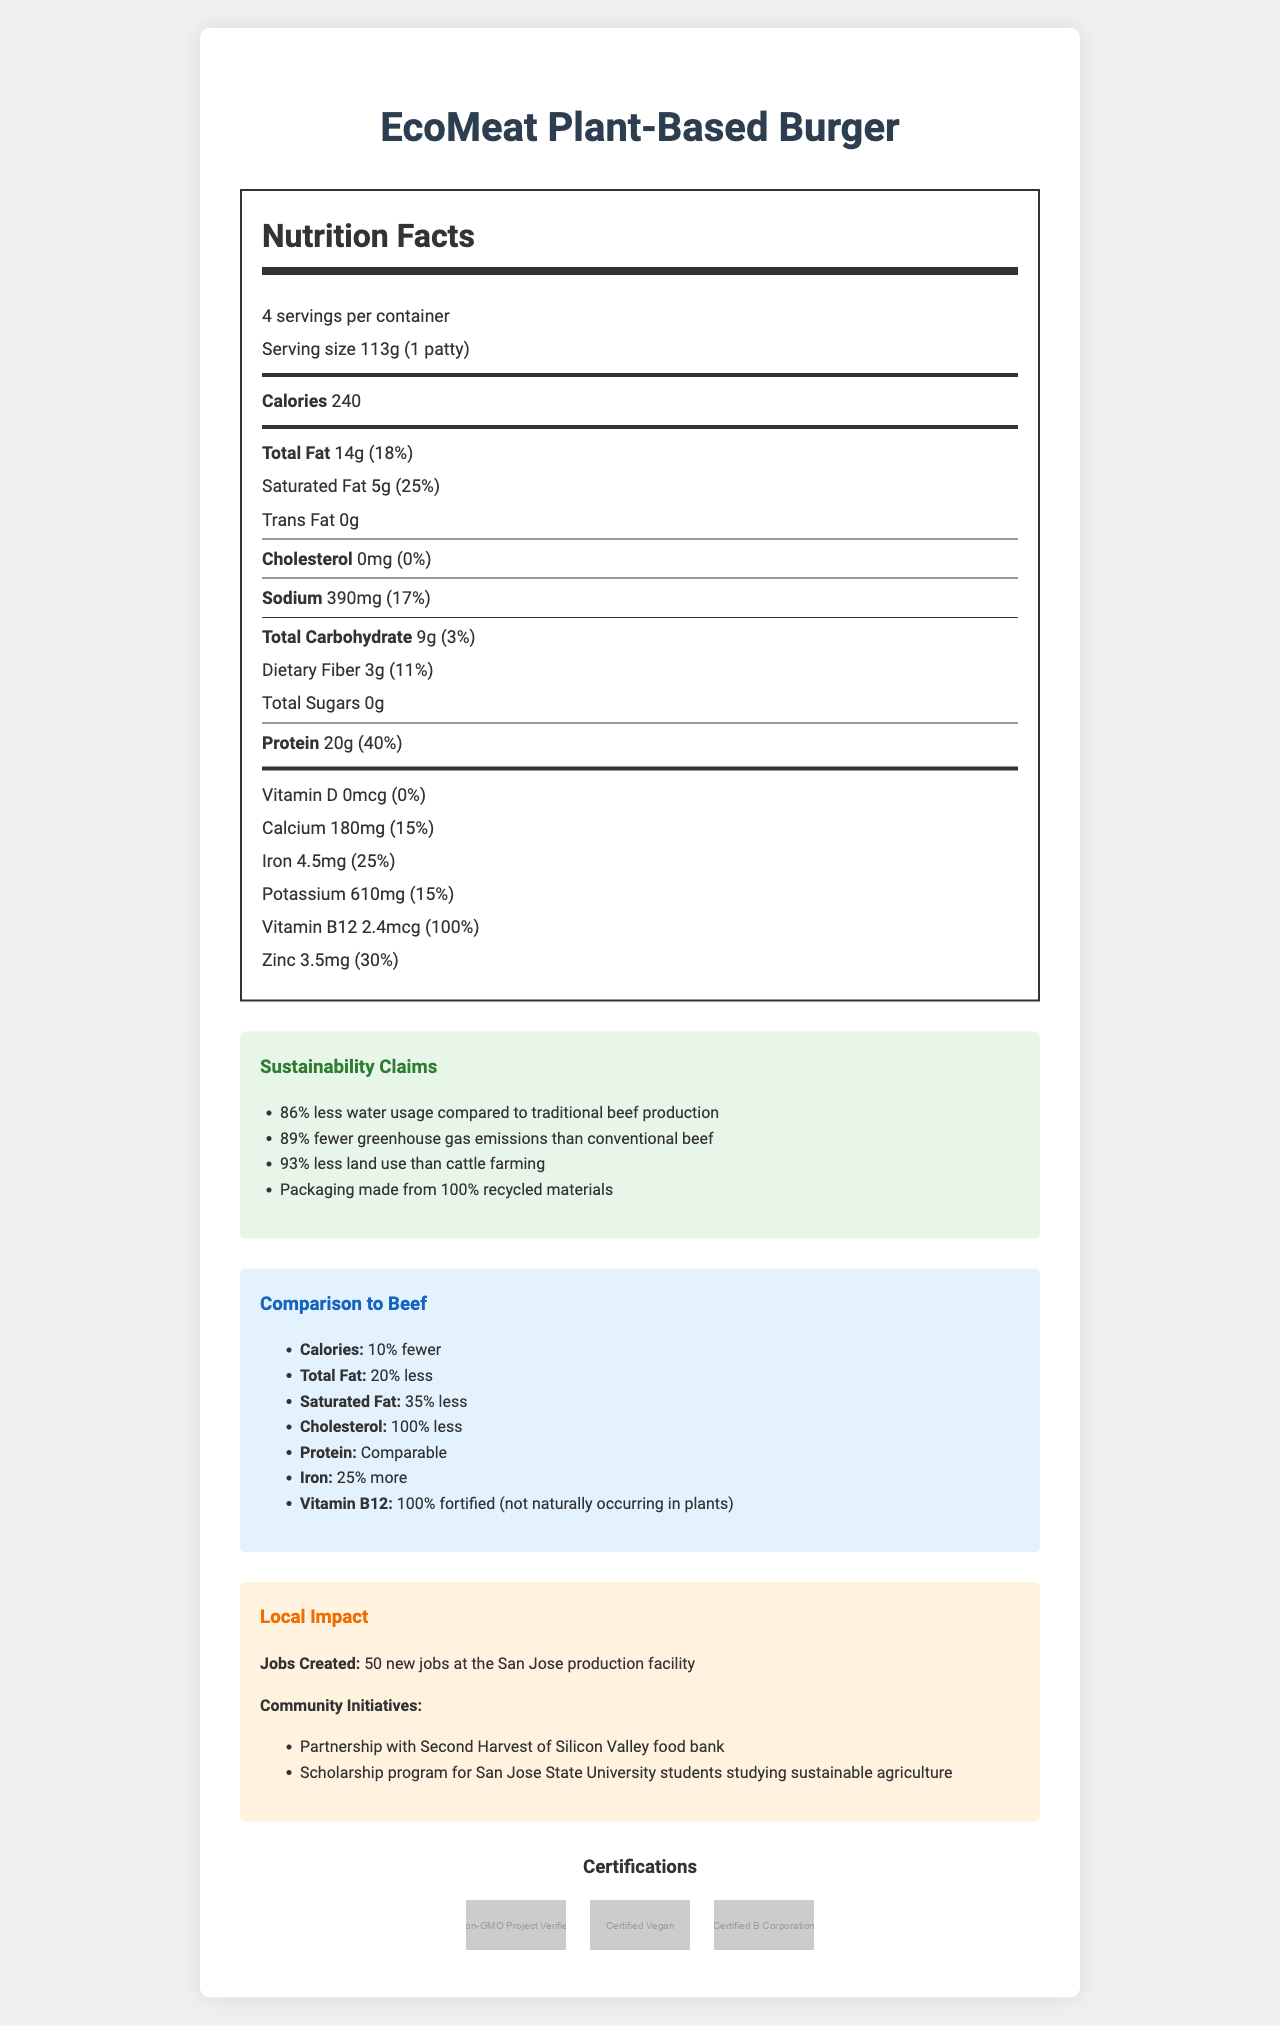what is the serving size for EcoMeat Plant-Based Burger? The serving size is specified as "113g (1 patty)" in the nutrition facts section.
Answer: 113g (1 patty) how many servings are there per container? The document states that there are 4 servings per container.
Answer: 4 servings how many calories are in one serving of the EcoMeat Plant-Based Burger? The number of calories per serving is listed as 240 in the nutrition facts.
Answer: 240 calories what percentage of the daily value is provided by the saturated fat in one serving? The document lists the saturated fat daily value as 25%.
Answer: 25% is there any cholesterol in the EcoMeat Plant-Based Burger? The nutrition facts show that the cholesterol amount is 0mg, which is 0% of the daily value.
Answer: No how much protein is in one serving of the EcoMeat Plant-Based Burger? The document states that one serving contains 20g of protein.
Answer: 20g what is the sustainability claim related to greenhouse gas emissions provided by EcoMeat Plant-Based Burger? A. 50% fewer B. 75% fewer C. 89% fewer The sustainability section mentions that EcoMeat Plant-Based Burger has "89% fewer greenhouse gas emissions than conventional beef."
Answer: C which of the following ingredients is used for coloring in EcoMeat Plant-Based Burger? A. Beet Juice Extract B. Turmeric C. Annatto The document mentions that Beet Juice Extract is used "for color."
Answer: A is EcoMeat Plant-Based Burger certified as Non-GMO? The certifications section includes "Non-GMO Project Verified."
Answer: Yes what is the main idea of this document? The document primarily details the nutritional information, sustainability claims, comparison to traditional beef, local impact, economic benefits, and various certifications of EcoMeat Plant-Based Burger.
Answer: EcoMeat Plant-Based Burger is a sustainable, plant-based meat alternative that offers nutritional advantages over traditional beef, along with significant environmental benefits and local community impact. by how much does the EcoMeat Plant-Based Burger reduce land use compared to conventional beef? The sustainability claims section states that the product uses "93% less land use than cattle farming."
Answer: 93% how does the protein content of EcoMeat Plant-Based Burger compare to traditional beef? The comparison to beef section states that the protein content is "Comparable" to traditional beef.
Answer: Comparable which vitamin in the EcoMeat Plant-Based Burger provides 100% of the daily value? A. Vitamin D B. Vitamin B12 C. Vitamin C The nutrition facts show that Vitamin B12 provides 100% of the daily value.
Answer: B are there any community initiatives associated with EcoMeat Plant-Based Burger in San Jose? The local impact section lists partnerships with Second Harvest of Silicon Valley food bank and a scholarship program for San Jose State University students studying sustainable agriculture.
Answer: Yes how much sodium is in one serving of EcoMeat Plant-Based Burger? The sodium content per serving is listed as 390mg in the nutrition facts section.
Answer: 390mg does the document provide the method to cook the EcoMeat Plant-Based Burger? The document does not mention any cooking methods for the EcoMeat Plant-Based Burger.
Answer: Not enough information 